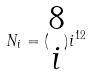<formula> <loc_0><loc_0><loc_500><loc_500>N _ { i } = ( \begin{matrix} 8 \\ i \end{matrix} ) i ^ { 1 2 }</formula> 